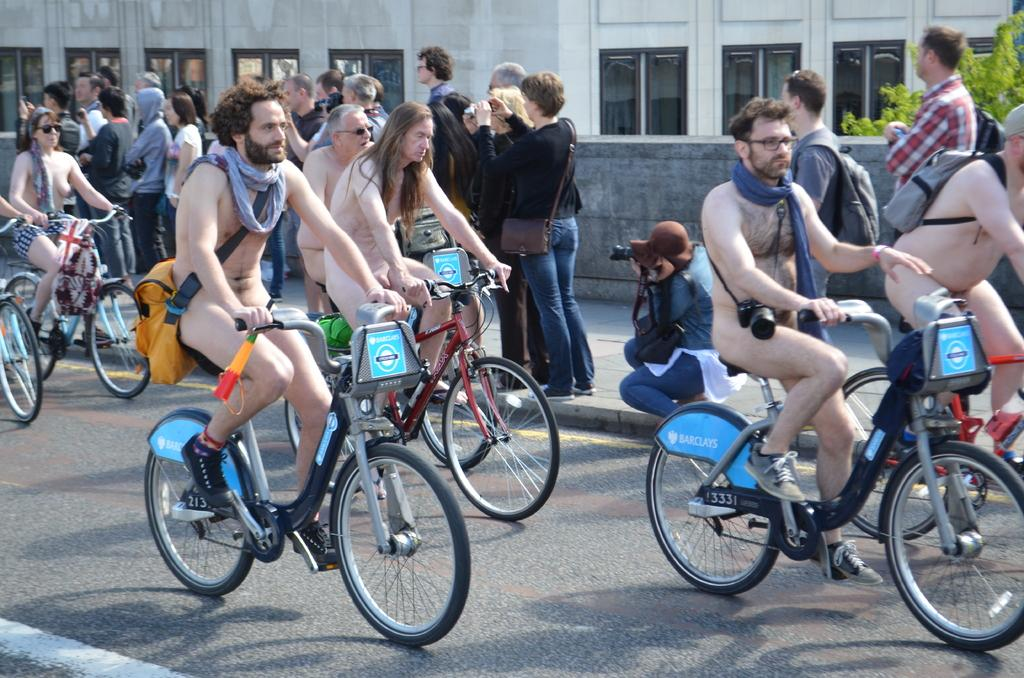What are the people on the road doing in the image? There are few people on the road cycling naked in the image. What are the people on the footpath doing in the image? There are several people on the footpath taking pictures in the image. What can be seen in the background of the image? There is a building in the background of the image. What type of vegetation is on the right side of the image? There is a tree on the right side of the image. What type of door can be seen on the building in the image? There is no door visible on the building in the image. What type of tin is being used by the people cycling naked in the image? There is no tin present in the image; the people are cycling naked. 